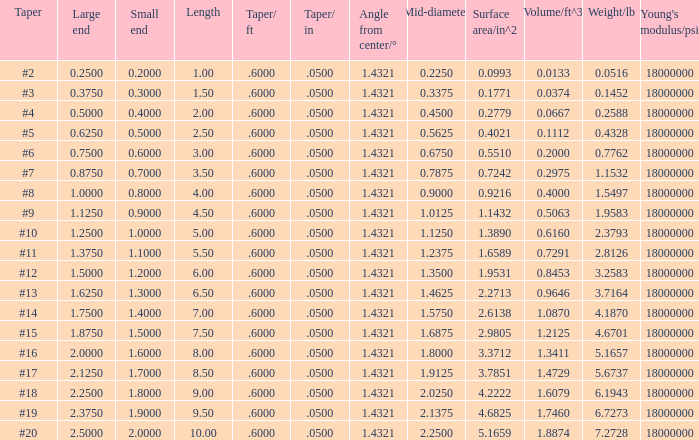Which Taper/in that has a Small end larger than 0.7000000000000001, and a Taper of #19, and a Large end larger than 2.375? None. 